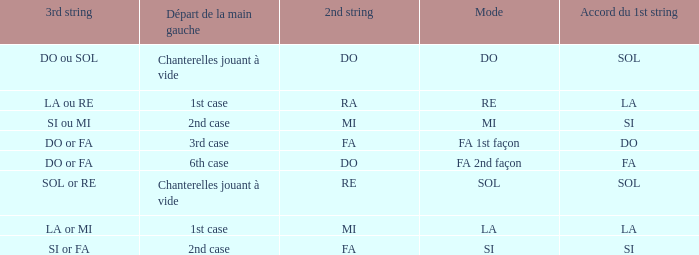What is the Depart de la main gauche of the do Mode? Chanterelles jouant à vide. 